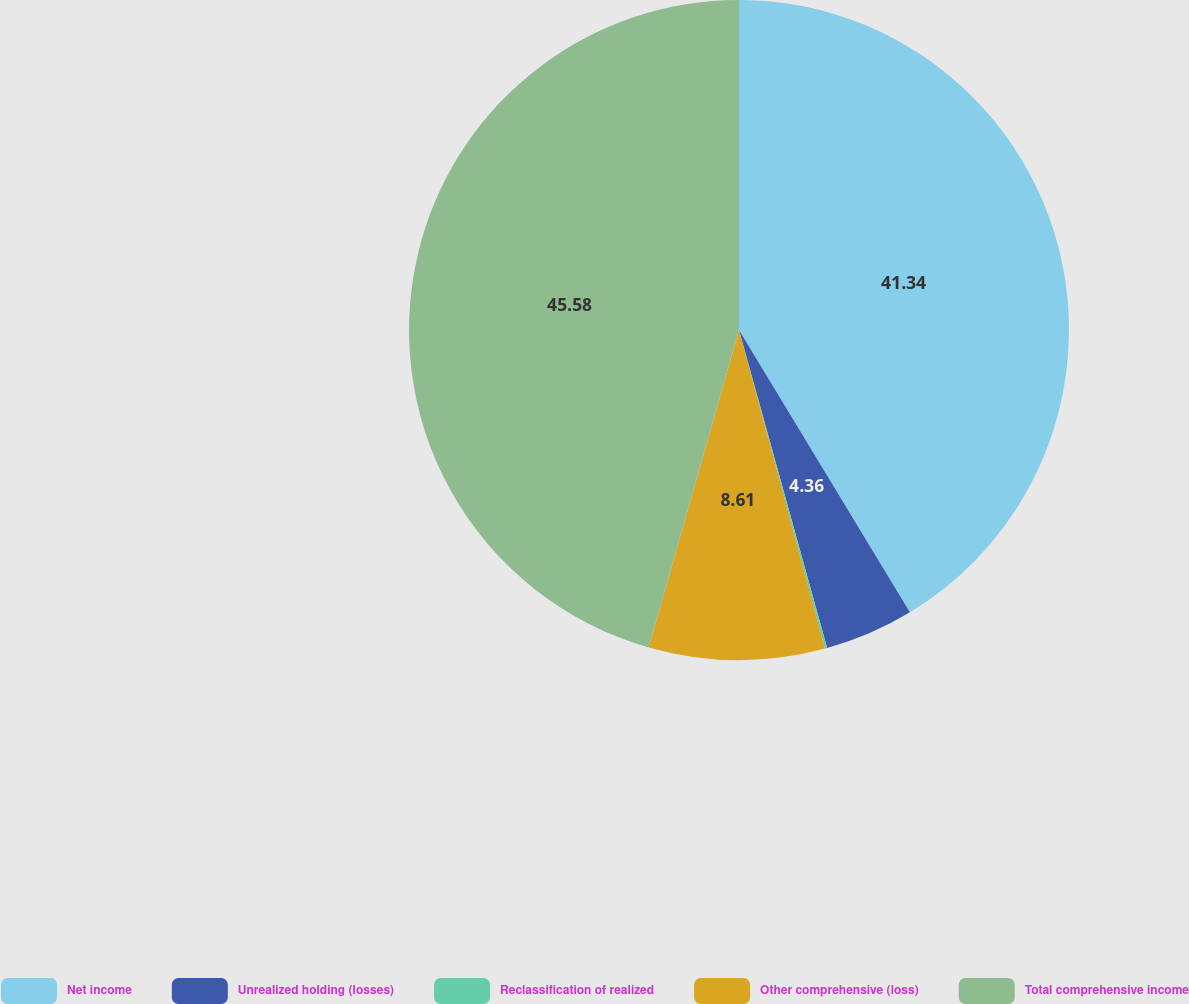Convert chart. <chart><loc_0><loc_0><loc_500><loc_500><pie_chart><fcel>Net income<fcel>Unrealized holding (losses)<fcel>Reclassification of realized<fcel>Other comprehensive (loss)<fcel>Total comprehensive income<nl><fcel>41.34%<fcel>4.36%<fcel>0.11%<fcel>8.61%<fcel>45.59%<nl></chart> 